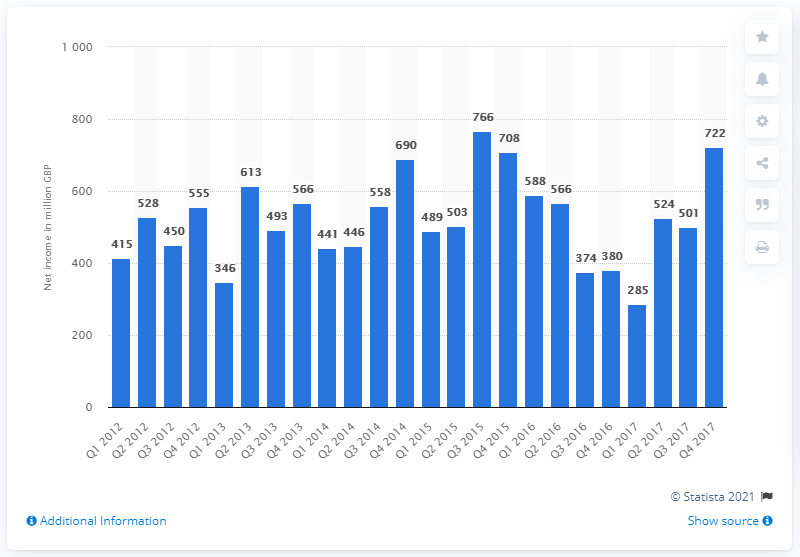Highlight a few significant elements in this photo. BT's net income in the fourth quarter of 2017/18 was 722. 